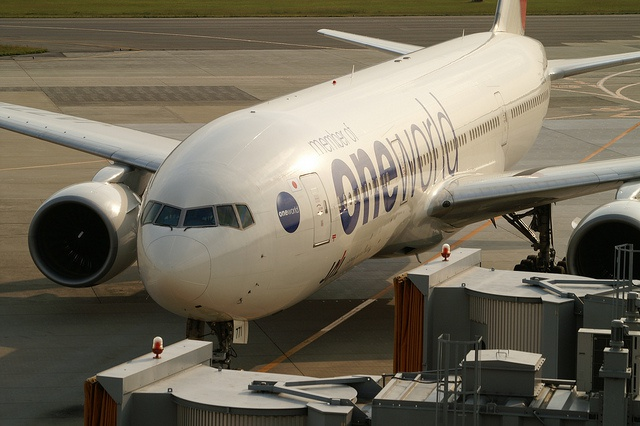Describe the objects in this image and their specific colors. I can see a airplane in darkgreen, beige, darkgray, black, and gray tones in this image. 